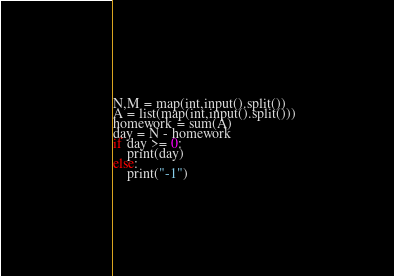Convert code to text. <code><loc_0><loc_0><loc_500><loc_500><_Python_>N,M = map(int,input().split())
A = list(map(int,input().split()))
homework = sum(A)
day = N - homework
if day >= 0:
    print(day)
else:
    print("-1")</code> 